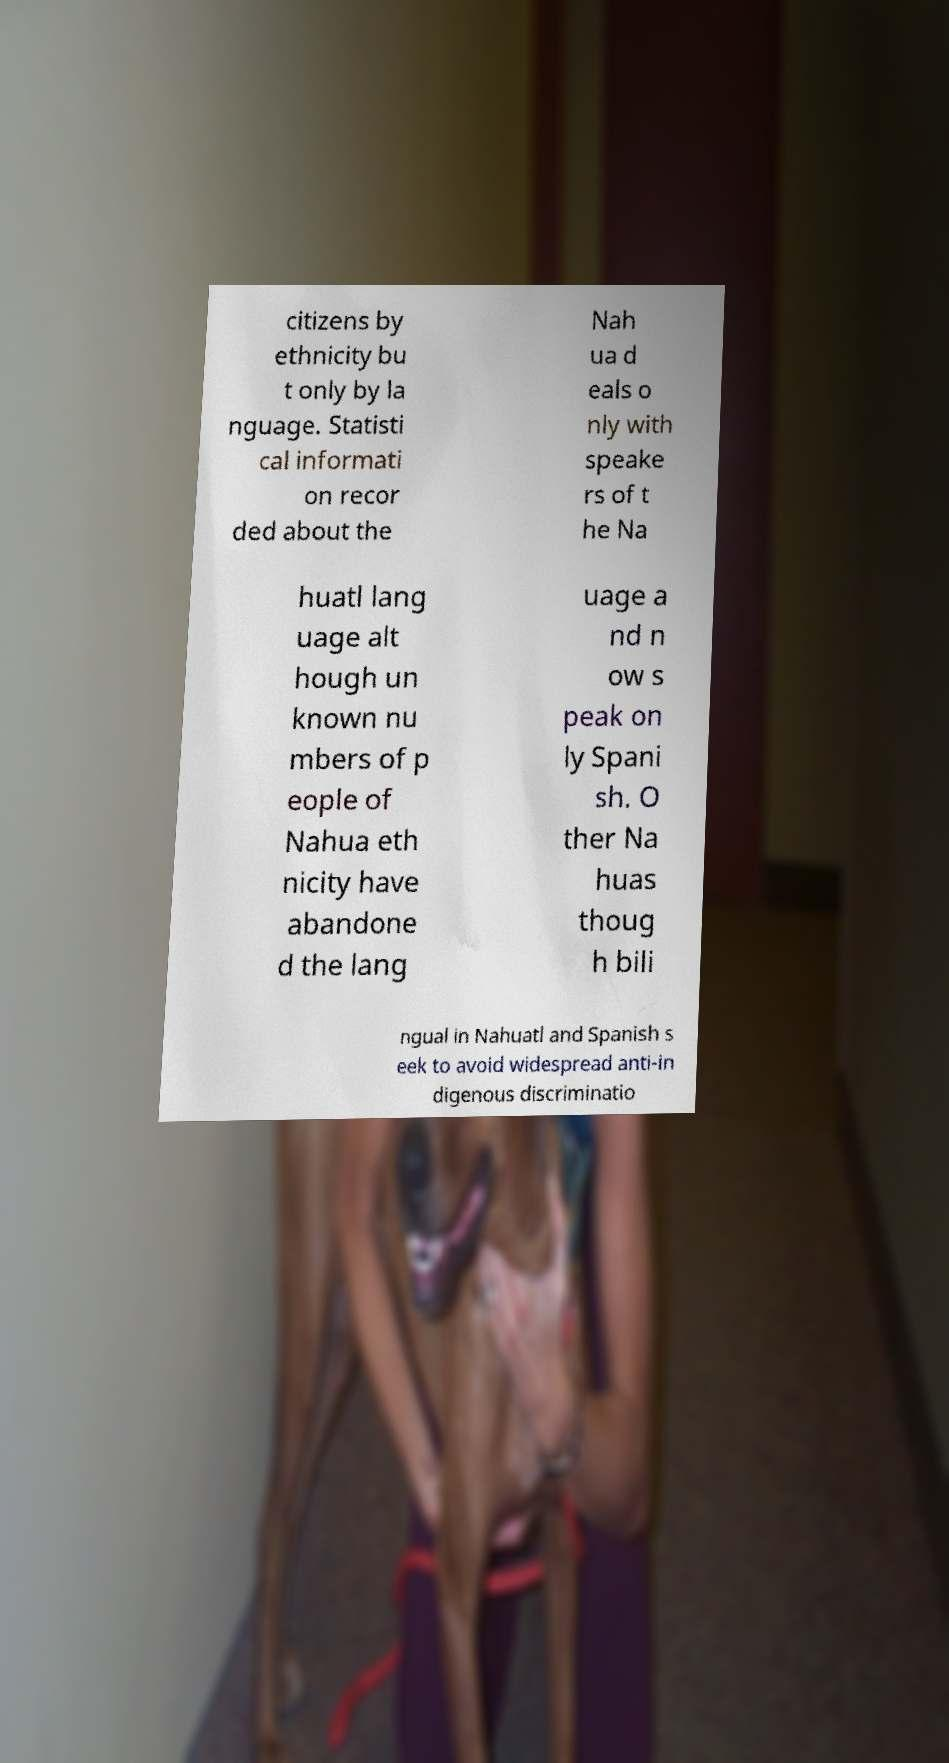Please identify and transcribe the text found in this image. citizens by ethnicity bu t only by la nguage. Statisti cal informati on recor ded about the Nah ua d eals o nly with speake rs of t he Na huatl lang uage alt hough un known nu mbers of p eople of Nahua eth nicity have abandone d the lang uage a nd n ow s peak on ly Spani sh. O ther Na huas thoug h bili ngual in Nahuatl and Spanish s eek to avoid widespread anti-in digenous discriminatio 